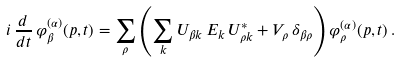<formula> <loc_0><loc_0><loc_500><loc_500>i \, \frac { d } { d t } \, \varphi ^ { ( \alpha ) } _ { \beta } ( p , t ) = \sum _ { \rho } \left ( \sum _ { k } U _ { { \beta } k } \, E _ { k } \, U _ { { \rho } k } ^ { * } + V _ { \rho } \, \delta _ { \beta \rho } \right ) \varphi ^ { ( \alpha ) } _ { \rho } ( p , t ) \, .</formula> 